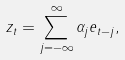Convert formula to latex. <formula><loc_0><loc_0><loc_500><loc_500>z _ { t } = \sum _ { j = - \infty } ^ { \infty } \alpha _ { j } e _ { t - j } ,</formula> 